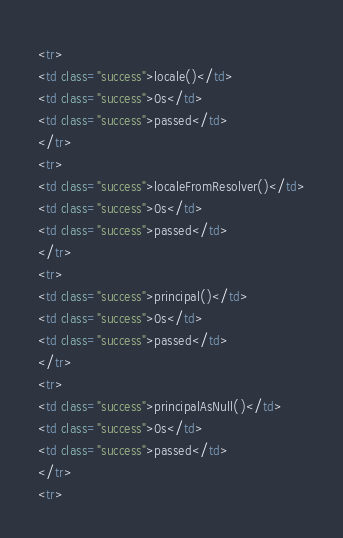Convert code to text. <code><loc_0><loc_0><loc_500><loc_500><_HTML_><tr>
<td class="success">locale()</td>
<td class="success">0s</td>
<td class="success">passed</td>
</tr>
<tr>
<td class="success">localeFromResolver()</td>
<td class="success">0s</td>
<td class="success">passed</td>
</tr>
<tr>
<td class="success">principal()</td>
<td class="success">0s</td>
<td class="success">passed</td>
</tr>
<tr>
<td class="success">principalAsNull()</td>
<td class="success">0s</td>
<td class="success">passed</td>
</tr>
<tr></code> 